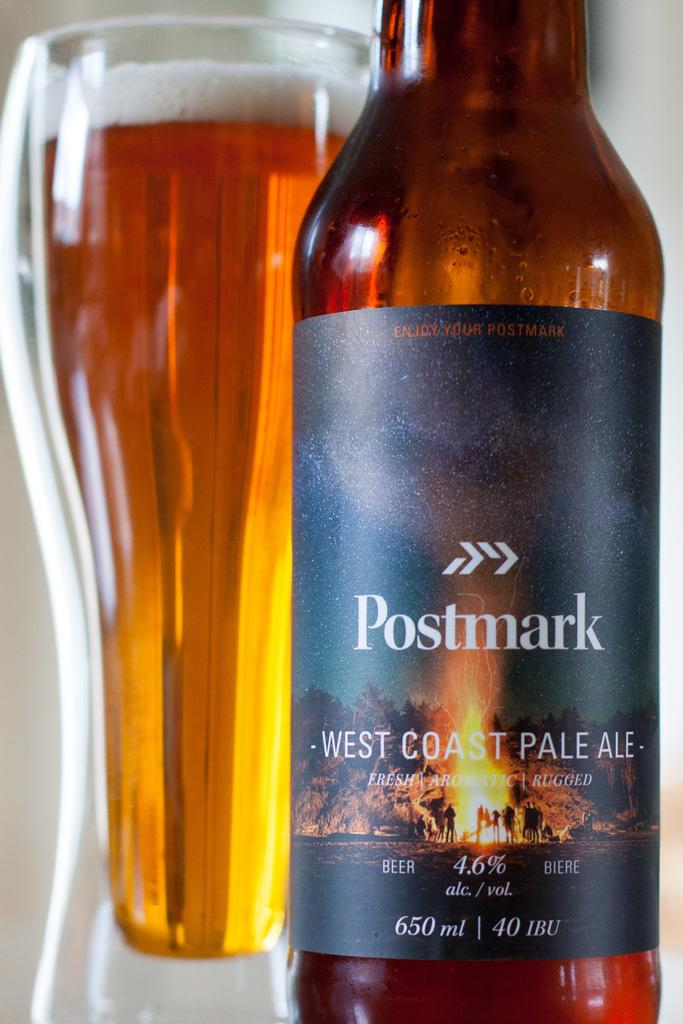<image>
Render a clear and concise summary of the photo. a cup and bottle of Postmark West Coast Pale Ale 